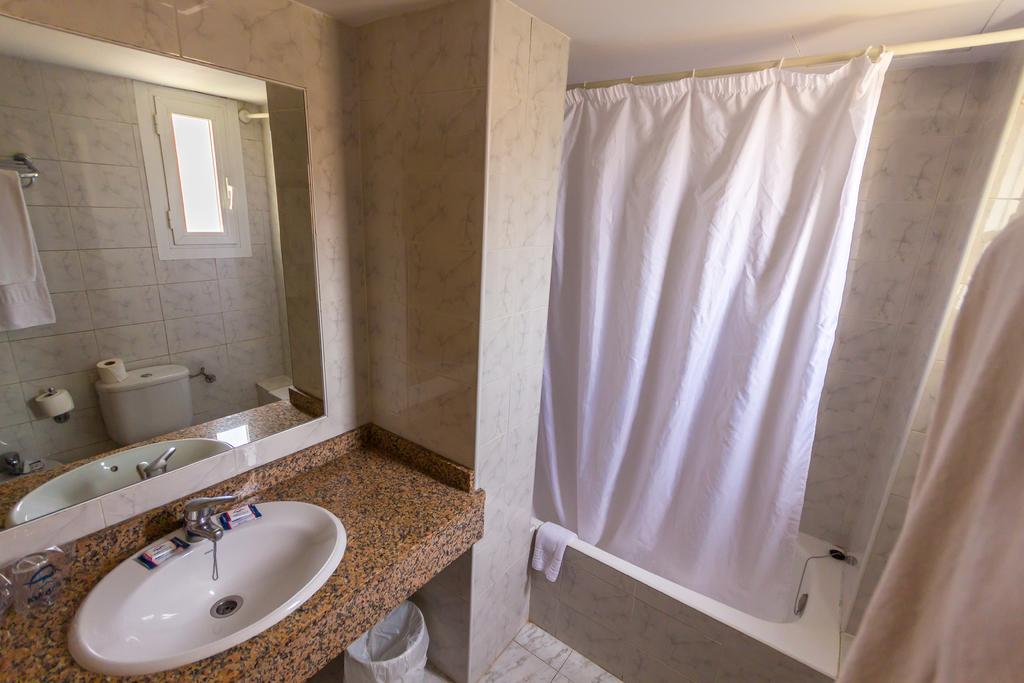What type of fixture is present in the image for washing hands? There is a wash basin in the image for washing hands. What can be used for personal grooming in the image? There is a mirror on the wall in the image for personal grooming. What type of fixture is present in the image for bathing? There is a bathtub in the image for bathing. What type of dog can be seen playing with a vegetable in the image? There is no dog or vegetable present in the image; it only features a wash basin, a mirror, and a bathtub. 